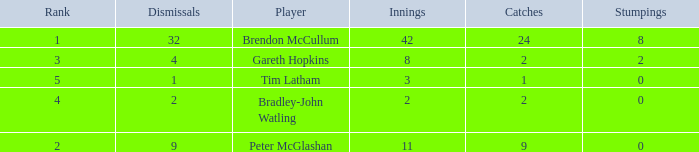Parse the table in full. {'header': ['Rank', 'Dismissals', 'Player', 'Innings', 'Catches', 'Stumpings'], 'rows': [['1', '32', 'Brendon McCullum', '42', '24', '8'], ['3', '4', 'Gareth Hopkins', '8', '2', '2'], ['5', '1', 'Tim Latham', '3', '1', '0'], ['4', '2', 'Bradley-John Watling', '2', '2', '0'], ['2', '9', 'Peter McGlashan', '11', '9', '0']]} How many dismissals did the player Peter McGlashan have? 9.0. 